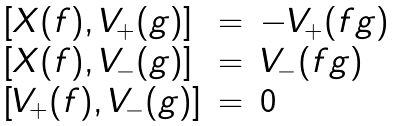<formula> <loc_0><loc_0><loc_500><loc_500>\begin{array} { l l l } \left [ X ( f ) , V _ { + } ( g ) \right ] & = & - V _ { + } ( f g ) \\ \left [ X ( f ) , V _ { - } ( g ) \right ] & = & V _ { - } ( f g ) \\ \left [ V _ { + } ( f ) , V _ { - } ( g ) \right ] & = & 0 \end{array}</formula> 